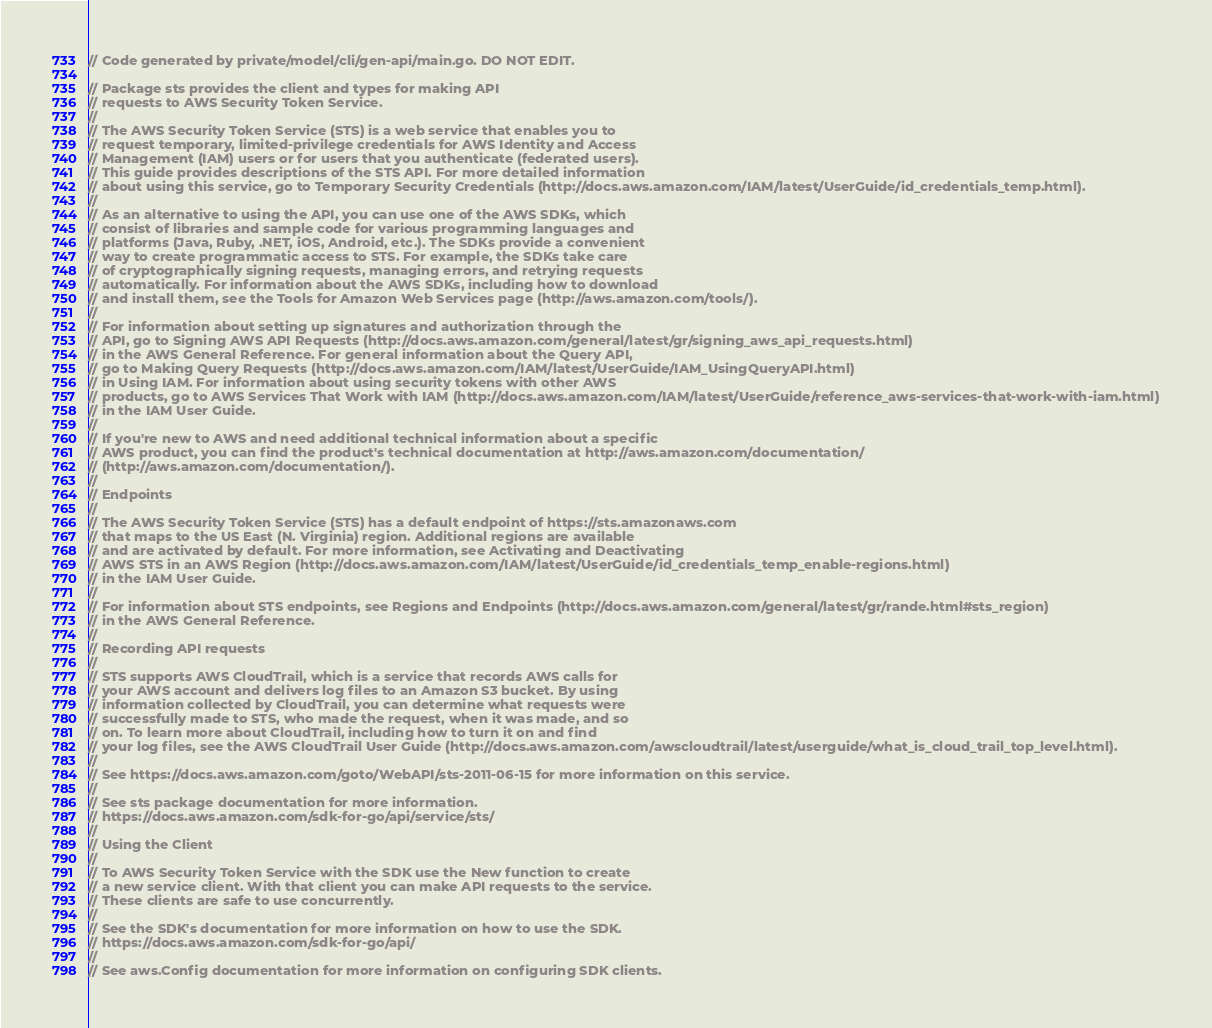<code> <loc_0><loc_0><loc_500><loc_500><_Go_>// Code generated by private/model/cli/gen-api/main.go. DO NOT EDIT.

// Package sts provides the client and types for making API
// requests to AWS Security Token Service.
//
// The AWS Security Token Service (STS) is a web service that enables you to
// request temporary, limited-privilege credentials for AWS Identity and Access
// Management (IAM) users or for users that you authenticate (federated users).
// This guide provides descriptions of the STS API. For more detailed information
// about using this service, go to Temporary Security Credentials (http://docs.aws.amazon.com/IAM/latest/UserGuide/id_credentials_temp.html).
//
// As an alternative to using the API, you can use one of the AWS SDKs, which
// consist of libraries and sample code for various programming languages and
// platforms (Java, Ruby, .NET, iOS, Android, etc.). The SDKs provide a convenient
// way to create programmatic access to STS. For example, the SDKs take care
// of cryptographically signing requests, managing errors, and retrying requests
// automatically. For information about the AWS SDKs, including how to download
// and install them, see the Tools for Amazon Web Services page (http://aws.amazon.com/tools/).
//
// For information about setting up signatures and authorization through the
// API, go to Signing AWS API Requests (http://docs.aws.amazon.com/general/latest/gr/signing_aws_api_requests.html)
// in the AWS General Reference. For general information about the Query API,
// go to Making Query Requests (http://docs.aws.amazon.com/IAM/latest/UserGuide/IAM_UsingQueryAPI.html)
// in Using IAM. For information about using security tokens with other AWS
// products, go to AWS Services That Work with IAM (http://docs.aws.amazon.com/IAM/latest/UserGuide/reference_aws-services-that-work-with-iam.html)
// in the IAM User Guide.
//
// If you're new to AWS and need additional technical information about a specific
// AWS product, you can find the product's technical documentation at http://aws.amazon.com/documentation/
// (http://aws.amazon.com/documentation/).
//
// Endpoints
//
// The AWS Security Token Service (STS) has a default endpoint of https://sts.amazonaws.com
// that maps to the US East (N. Virginia) region. Additional regions are available
// and are activated by default. For more information, see Activating and Deactivating
// AWS STS in an AWS Region (http://docs.aws.amazon.com/IAM/latest/UserGuide/id_credentials_temp_enable-regions.html)
// in the IAM User Guide.
//
// For information about STS endpoints, see Regions and Endpoints (http://docs.aws.amazon.com/general/latest/gr/rande.html#sts_region)
// in the AWS General Reference.
//
// Recording API requests
//
// STS supports AWS CloudTrail, which is a service that records AWS calls for
// your AWS account and delivers log files to an Amazon S3 bucket. By using
// information collected by CloudTrail, you can determine what requests were
// successfully made to STS, who made the request, when it was made, and so
// on. To learn more about CloudTrail, including how to turn it on and find
// your log files, see the AWS CloudTrail User Guide (http://docs.aws.amazon.com/awscloudtrail/latest/userguide/what_is_cloud_trail_top_level.html).
//
// See https://docs.aws.amazon.com/goto/WebAPI/sts-2011-06-15 for more information on this service.
//
// See sts package documentation for more information.
// https://docs.aws.amazon.com/sdk-for-go/api/service/sts/
//
// Using the Client
//
// To AWS Security Token Service with the SDK use the New function to create
// a new service client. With that client you can make API requests to the service.
// These clients are safe to use concurrently.
//
// See the SDK's documentation for more information on how to use the SDK.
// https://docs.aws.amazon.com/sdk-for-go/api/
//
// See aws.Config documentation for more information on configuring SDK clients.</code> 